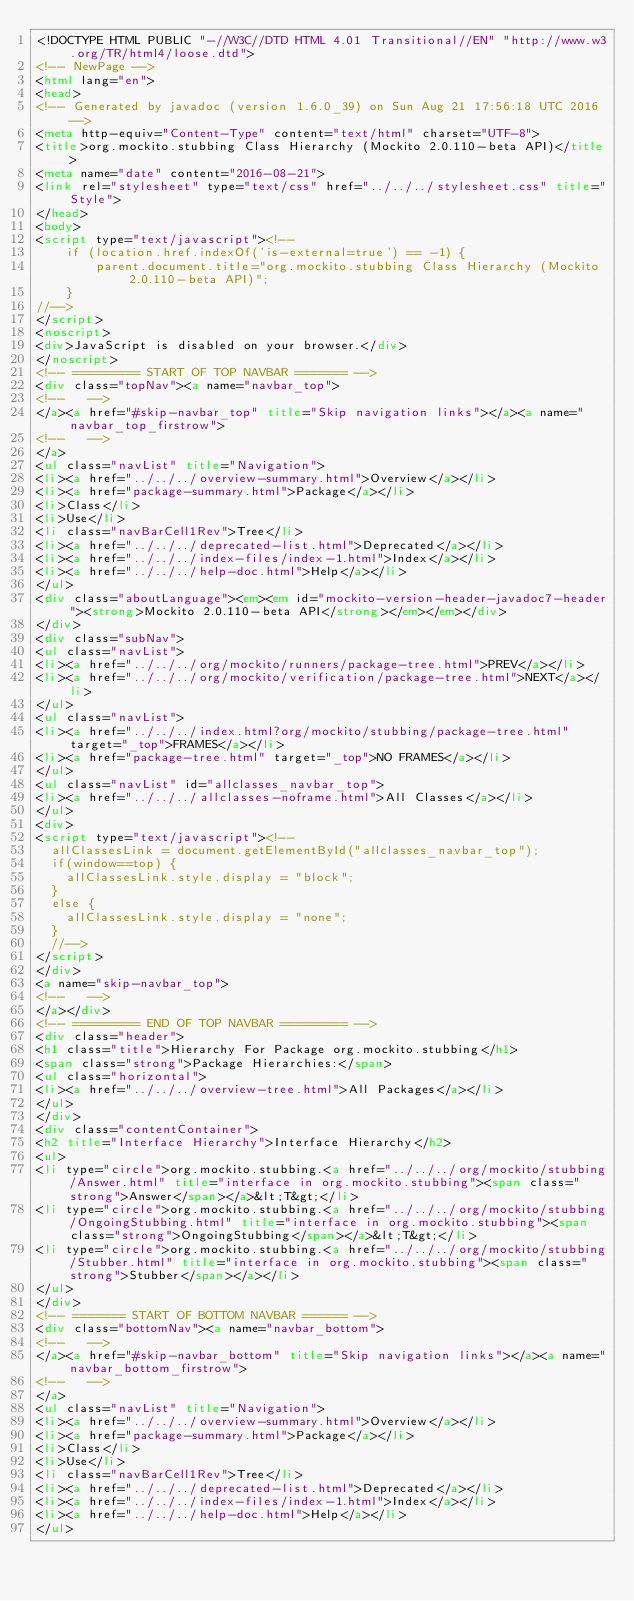Convert code to text. <code><loc_0><loc_0><loc_500><loc_500><_HTML_><!DOCTYPE HTML PUBLIC "-//W3C//DTD HTML 4.01 Transitional//EN" "http://www.w3.org/TR/html4/loose.dtd">
<!-- NewPage -->
<html lang="en">
<head>
<!-- Generated by javadoc (version 1.6.0_39) on Sun Aug 21 17:56:18 UTC 2016 -->
<meta http-equiv="Content-Type" content="text/html" charset="UTF-8">
<title>org.mockito.stubbing Class Hierarchy (Mockito 2.0.110-beta API)</title>
<meta name="date" content="2016-08-21">
<link rel="stylesheet" type="text/css" href="../../../stylesheet.css" title="Style">
</head>
<body>
<script type="text/javascript"><!--
    if (location.href.indexOf('is-external=true') == -1) {
        parent.document.title="org.mockito.stubbing Class Hierarchy (Mockito 2.0.110-beta API)";
    }
//-->
</script>
<noscript>
<div>JavaScript is disabled on your browser.</div>
</noscript>
<!-- ========= START OF TOP NAVBAR ======= -->
<div class="topNav"><a name="navbar_top">
<!--   -->
</a><a href="#skip-navbar_top" title="Skip navigation links"></a><a name="navbar_top_firstrow">
<!--   -->
</a>
<ul class="navList" title="Navigation">
<li><a href="../../../overview-summary.html">Overview</a></li>
<li><a href="package-summary.html">Package</a></li>
<li>Class</li>
<li>Use</li>
<li class="navBarCell1Rev">Tree</li>
<li><a href="../../../deprecated-list.html">Deprecated</a></li>
<li><a href="../../../index-files/index-1.html">Index</a></li>
<li><a href="../../../help-doc.html">Help</a></li>
</ul>
<div class="aboutLanguage"><em><em id="mockito-version-header-javadoc7-header"><strong>Mockito 2.0.110-beta API</strong></em></em></div>
</div>
<div class="subNav">
<ul class="navList">
<li><a href="../../../org/mockito/runners/package-tree.html">PREV</a></li>
<li><a href="../../../org/mockito/verification/package-tree.html">NEXT</a></li>
</ul>
<ul class="navList">
<li><a href="../../../index.html?org/mockito/stubbing/package-tree.html" target="_top">FRAMES</a></li>
<li><a href="package-tree.html" target="_top">NO FRAMES</a></li>
</ul>
<ul class="navList" id="allclasses_navbar_top">
<li><a href="../../../allclasses-noframe.html">All Classes</a></li>
</ul>
<div>
<script type="text/javascript"><!--
  allClassesLink = document.getElementById("allclasses_navbar_top");
  if(window==top) {
    allClassesLink.style.display = "block";
  }
  else {
    allClassesLink.style.display = "none";
  }
  //-->
</script>
</div>
<a name="skip-navbar_top">
<!--   -->
</a></div>
<!-- ========= END OF TOP NAVBAR ========= -->
<div class="header">
<h1 class="title">Hierarchy For Package org.mockito.stubbing</h1>
<span class="strong">Package Hierarchies:</span>
<ul class="horizontal">
<li><a href="../../../overview-tree.html">All Packages</a></li>
</ul>
</div>
<div class="contentContainer">
<h2 title="Interface Hierarchy">Interface Hierarchy</h2>
<ul>
<li type="circle">org.mockito.stubbing.<a href="../../../org/mockito/stubbing/Answer.html" title="interface in org.mockito.stubbing"><span class="strong">Answer</span></a>&lt;T&gt;</li>
<li type="circle">org.mockito.stubbing.<a href="../../../org/mockito/stubbing/OngoingStubbing.html" title="interface in org.mockito.stubbing"><span class="strong">OngoingStubbing</span></a>&lt;T&gt;</li>
<li type="circle">org.mockito.stubbing.<a href="../../../org/mockito/stubbing/Stubber.html" title="interface in org.mockito.stubbing"><span class="strong">Stubber</span></a></li>
</ul>
</div>
<!-- ======= START OF BOTTOM NAVBAR ====== -->
<div class="bottomNav"><a name="navbar_bottom">
<!--   -->
</a><a href="#skip-navbar_bottom" title="Skip navigation links"></a><a name="navbar_bottom_firstrow">
<!--   -->
</a>
<ul class="navList" title="Navigation">
<li><a href="../../../overview-summary.html">Overview</a></li>
<li><a href="package-summary.html">Package</a></li>
<li>Class</li>
<li>Use</li>
<li class="navBarCell1Rev">Tree</li>
<li><a href="../../../deprecated-list.html">Deprecated</a></li>
<li><a href="../../../index-files/index-1.html">Index</a></li>
<li><a href="../../../help-doc.html">Help</a></li>
</ul></code> 